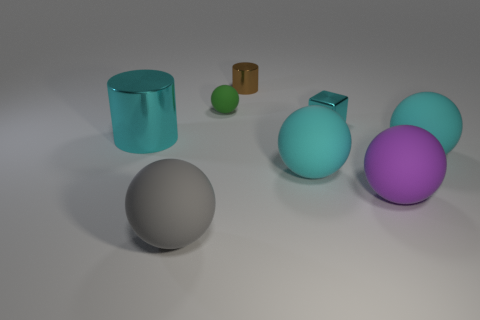There is a gray object that is the same size as the purple ball; what material is it?
Offer a very short reply. Rubber. How many other things are there of the same material as the brown cylinder?
Your answer should be very brief. 2. Does the small metal thing on the right side of the brown metal cylinder have the same shape as the big cyan metal object left of the small cyan object?
Provide a succinct answer. No. What is the color of the ball that is behind the shiny thing that is to the left of the matte thing that is behind the metallic cube?
Your response must be concise. Green. What number of other objects are there of the same color as the big cylinder?
Provide a succinct answer. 3. Are there fewer gray objects than big cyan objects?
Your response must be concise. Yes. The sphere that is both in front of the tiny cube and on the left side of the brown cylinder is what color?
Offer a terse response. Gray. What material is the purple thing that is the same shape as the large gray object?
Make the answer very short. Rubber. Is there anything else that has the same size as the cyan metallic cube?
Provide a succinct answer. Yes. Are there more rubber spheres than small gray matte cubes?
Ensure brevity in your answer.  Yes. 